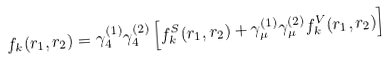Convert formula to latex. <formula><loc_0><loc_0><loc_500><loc_500>f _ { k } ( r _ { 1 } , r _ { 2 } ) = \gamma _ { 4 } ^ { ( 1 ) } \gamma _ { 4 } ^ { ( 2 ) } \left [ f _ { k } ^ { S } ( r _ { 1 } , r _ { 2 } ) + \gamma _ { \mu } ^ { ( 1 ) } \gamma _ { \mu } ^ { ( 2 ) } f _ { k } ^ { V } ( r _ { 1 } , r _ { 2 } ) \right ]</formula> 